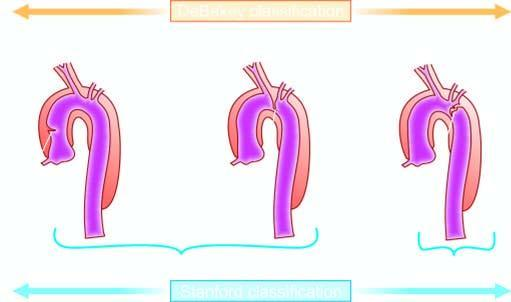s mucicarmine limited to descending aorta?
Answer the question using a single word or phrase. No 